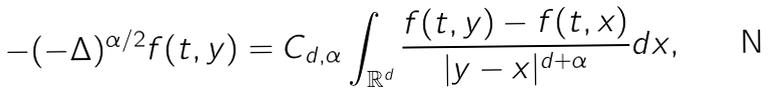<formula> <loc_0><loc_0><loc_500><loc_500>- ( - \Delta ) ^ { \alpha / 2 } f ( t , y ) = C _ { d , \alpha } \int _ { \mathbb { R } ^ { d } } \frac { f ( t , y ) - f ( t , x ) } { | y - x | ^ { d + \alpha } } d x ,</formula> 